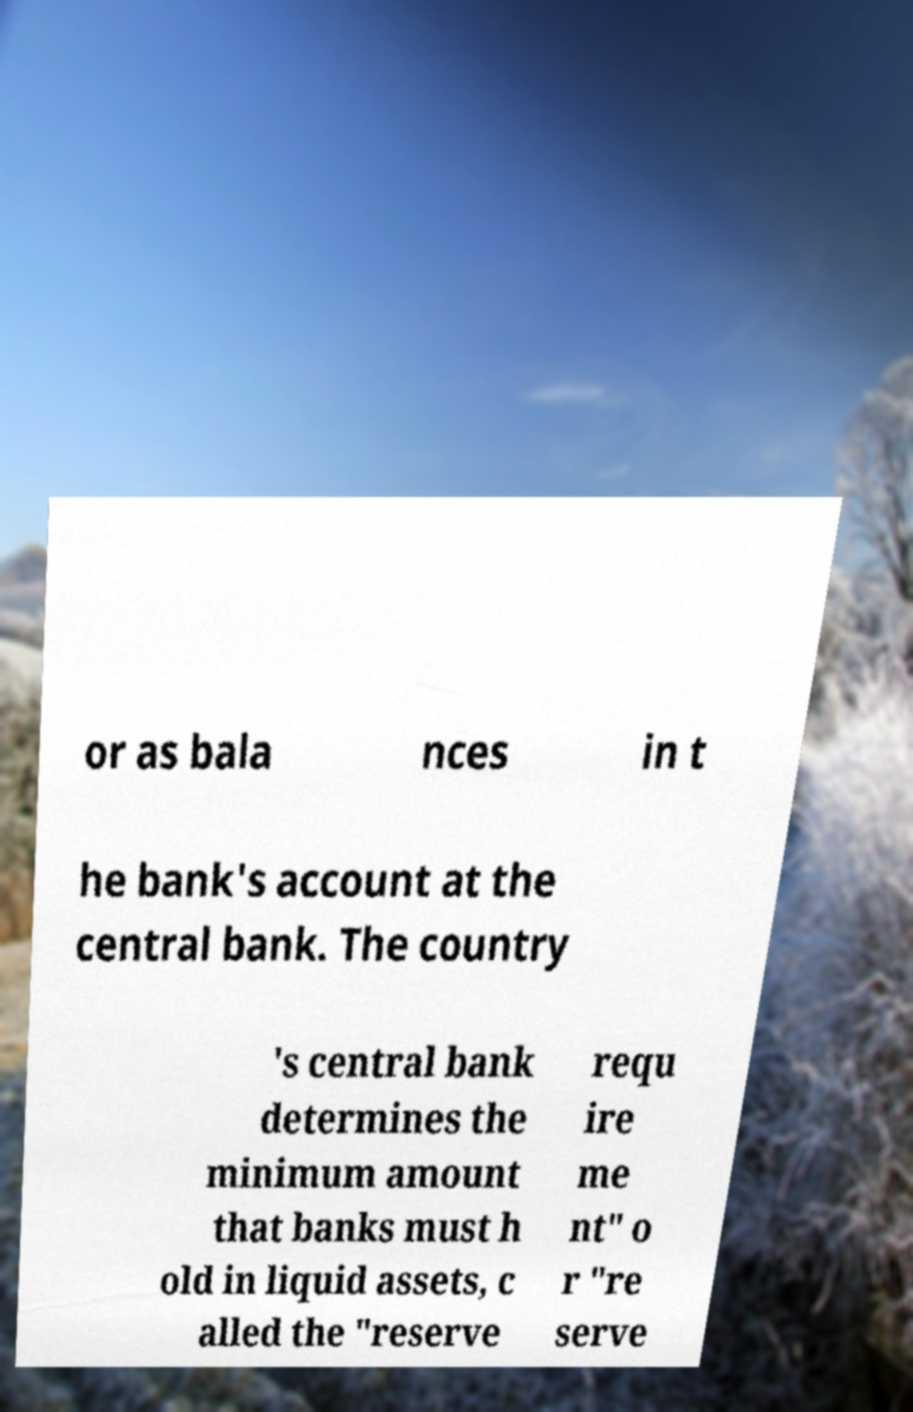Please read and relay the text visible in this image. What does it say? or as bala nces in t he bank's account at the central bank. The country 's central bank determines the minimum amount that banks must h old in liquid assets, c alled the "reserve requ ire me nt" o r "re serve 